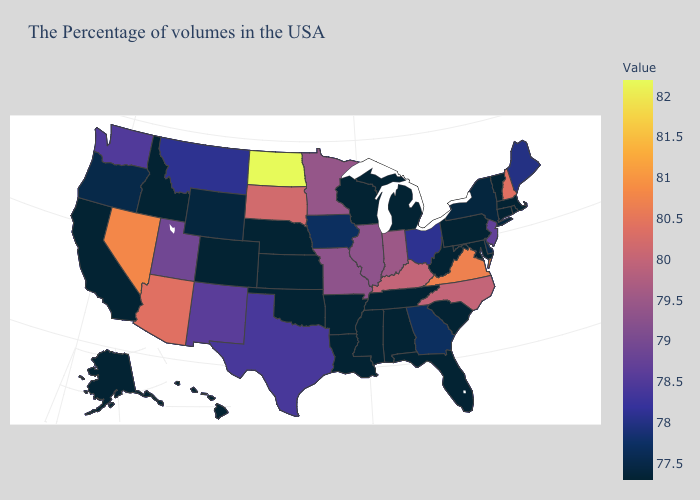Does Idaho have the highest value in the West?
Keep it brief. No. Among the states that border Kansas , does Missouri have the highest value?
Quick response, please. Yes. Among the states that border Washington , which have the lowest value?
Answer briefly. Idaho. Which states have the lowest value in the West?
Short answer required. Colorado, Idaho, California, Alaska, Hawaii. Is the legend a continuous bar?
Keep it brief. Yes. 